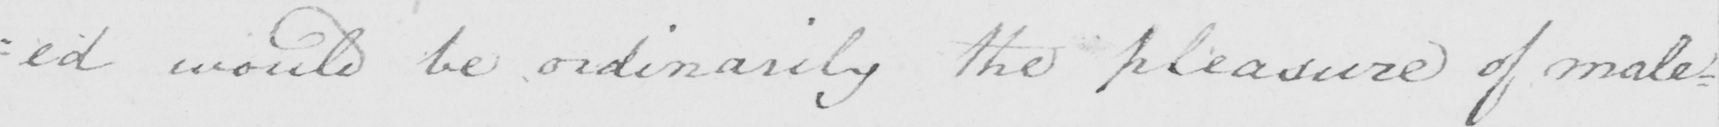What text is written in this handwritten line? : ed would be ordinarily the pleasure of male= 